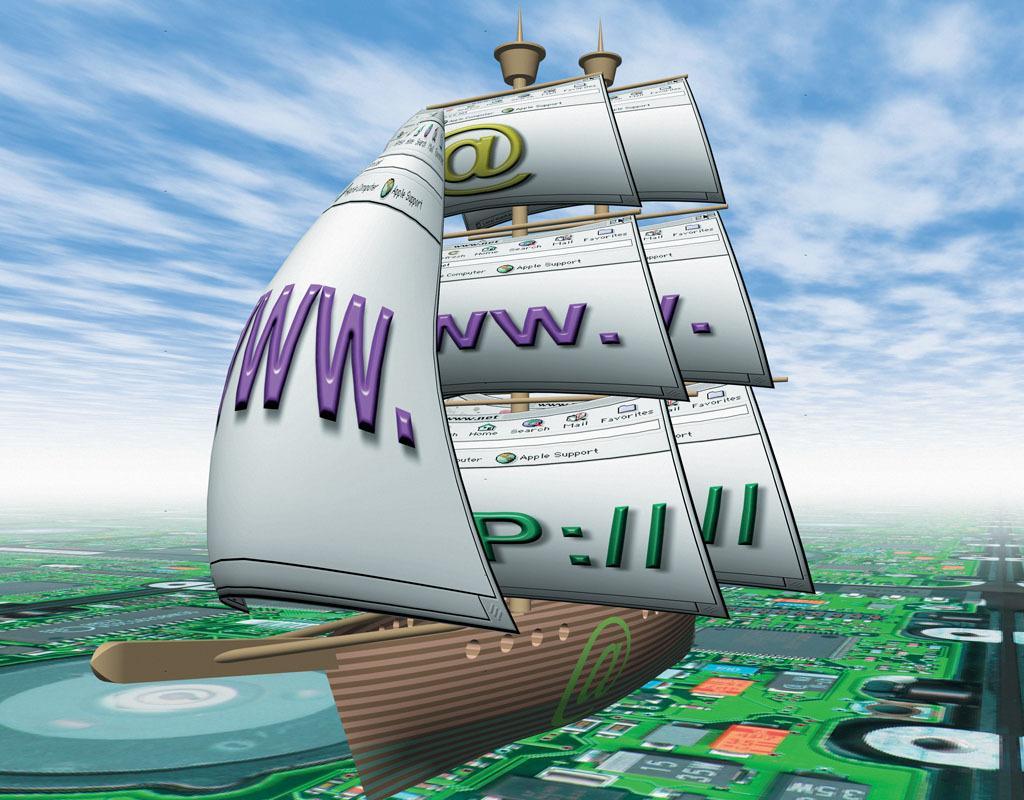In one or two sentences, can you explain what this image depicts? This picture is an animated picture. In the center there is a boat. In the background there is a motherboard. On the top there is a sky with clouds. 